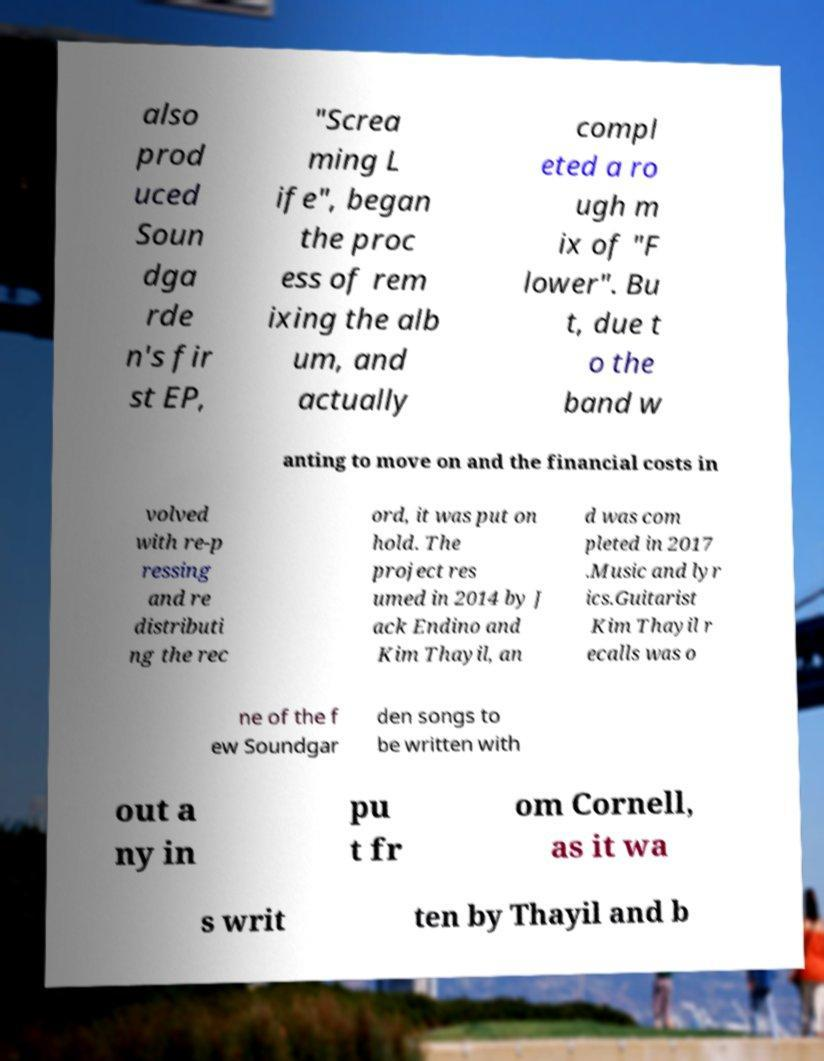Can you accurately transcribe the text from the provided image for me? also prod uced Soun dga rde n's fir st EP, "Screa ming L ife", began the proc ess of rem ixing the alb um, and actually compl eted a ro ugh m ix of "F lower". Bu t, due t o the band w anting to move on and the financial costs in volved with re-p ressing and re distributi ng the rec ord, it was put on hold. The project res umed in 2014 by J ack Endino and Kim Thayil, an d was com pleted in 2017 .Music and lyr ics.Guitarist Kim Thayil r ecalls was o ne of the f ew Soundgar den songs to be written with out a ny in pu t fr om Cornell, as it wa s writ ten by Thayil and b 